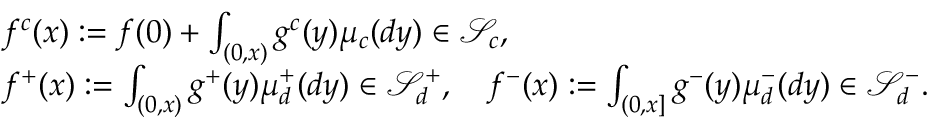Convert formula to latex. <formula><loc_0><loc_0><loc_500><loc_500>\begin{array} { r l } & { f ^ { c } ( x ) \colon = f ( 0 ) + \int _ { ( 0 , x ) } g ^ { c } ( y ) \mu _ { c } ( d y ) \in \ m a t h s c r { S } _ { c } , } \\ & { f ^ { + } ( x ) \colon = \int _ { ( 0 , x ) } g ^ { + } ( y ) \mu _ { d } ^ { + } ( d y ) \in \ m a t h s c r { S } _ { d } ^ { + } , \quad f ^ { - } ( x ) \colon = \int _ { ( 0 , x ] } g ^ { - } ( y ) \mu _ { d } ^ { - } ( d y ) \in \ m a t h s c r { S } _ { d } ^ { - } . } \end{array}</formula> 